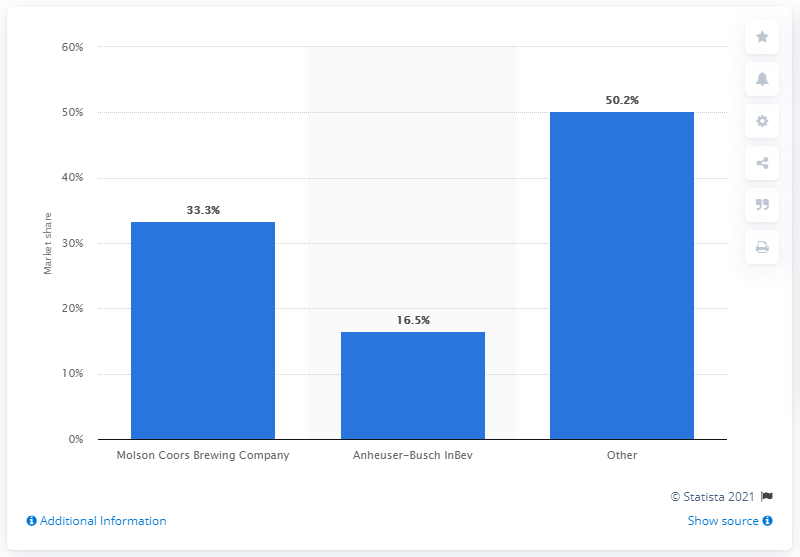Outline some significant characteristics in this image. As of October 2019, Molson Coors Brewing Company was the leading brewing company in Canada. The market share of all other brewing companies was 50.2%. Molson Coors Brewing Company's primary competitor is Anheuser-Busch InBev. Anheuser-Busch InBev holds a market share of 16.5%. 